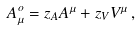Convert formula to latex. <formula><loc_0><loc_0><loc_500><loc_500>A _ { \mu } ^ { o } = z _ { A } A ^ { \mu } + z _ { V } V ^ { \mu } \, ,</formula> 